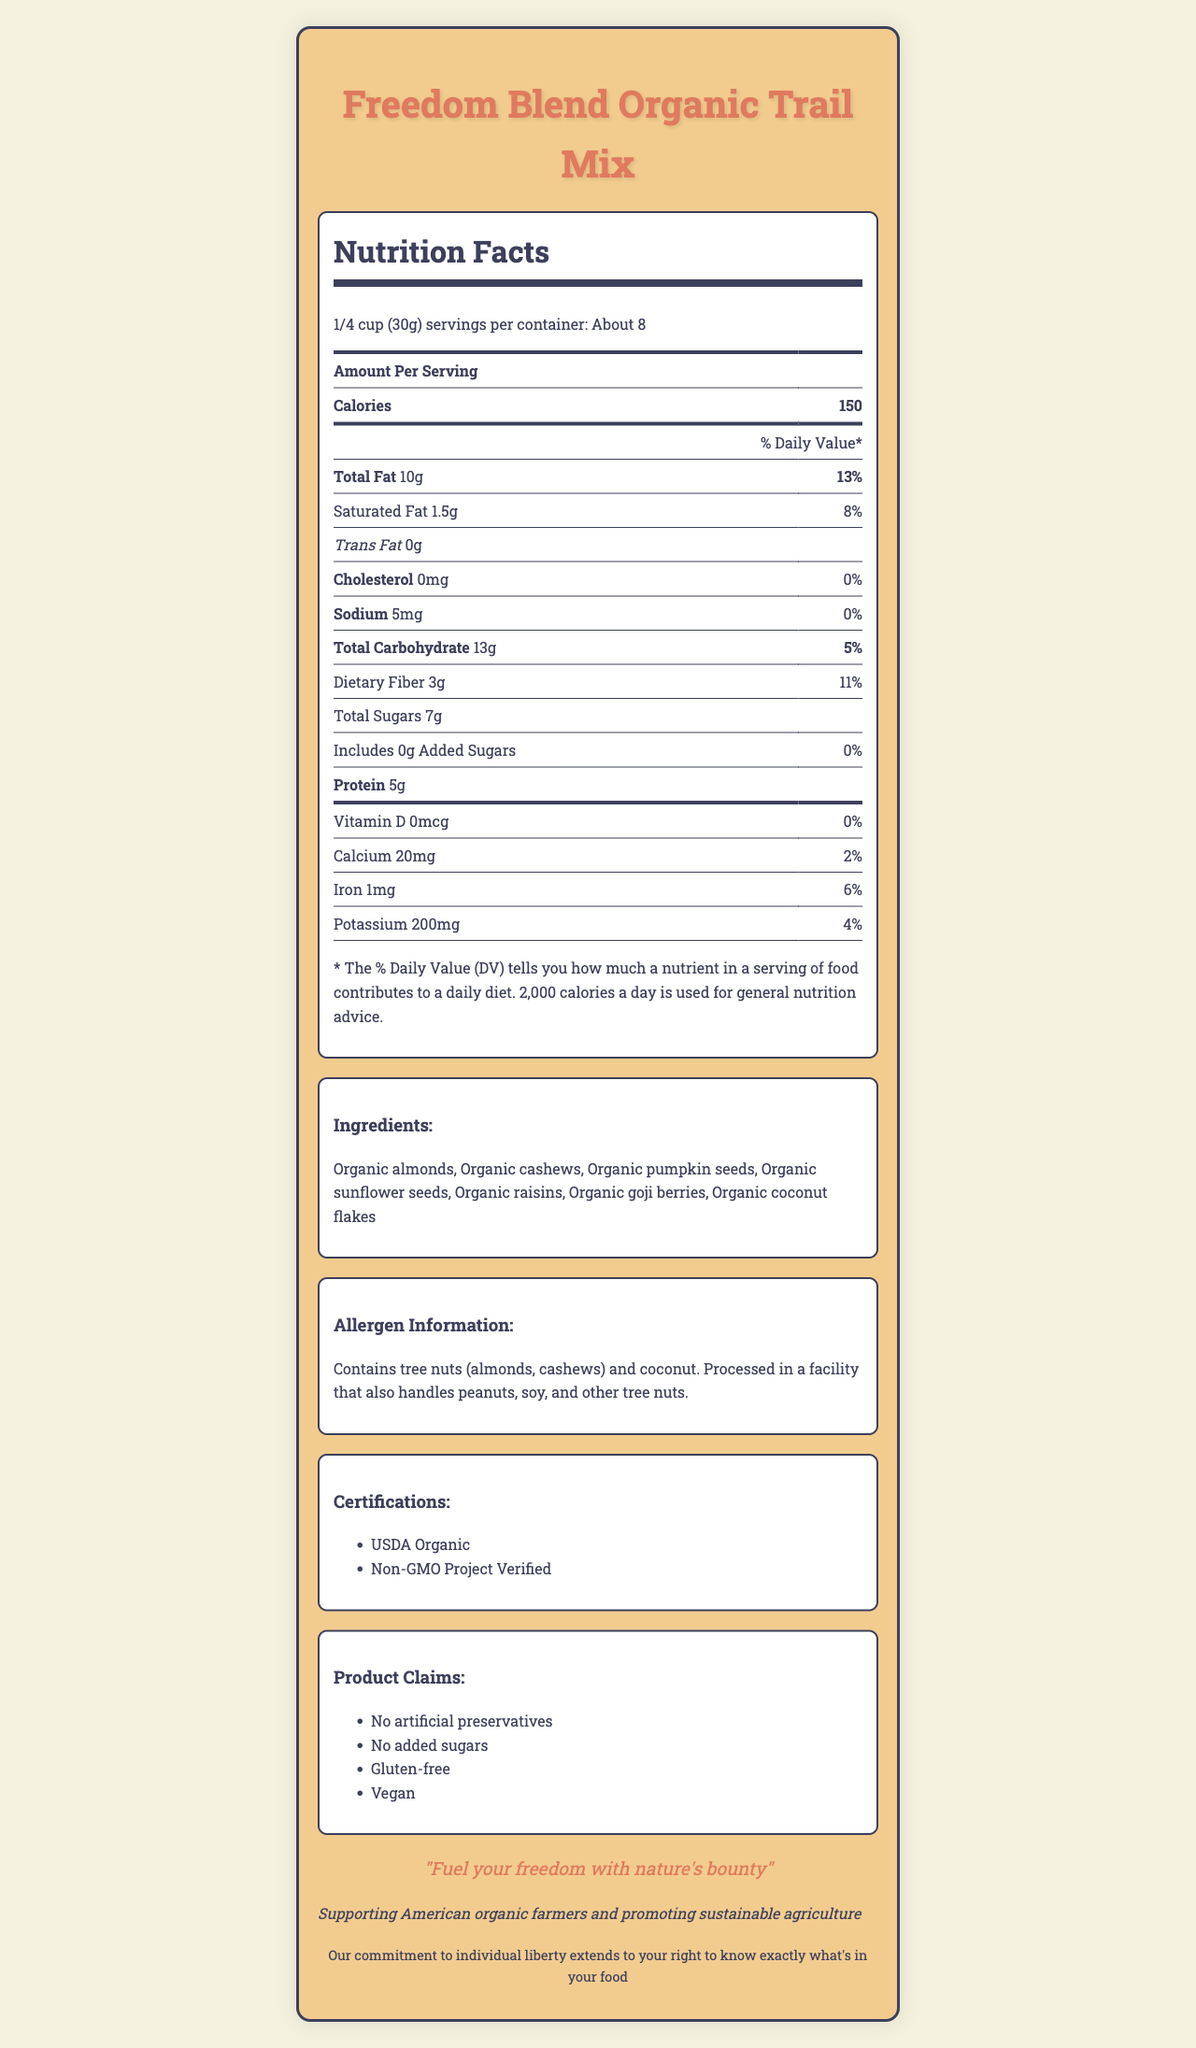1. What is the serving size of the Freedom Blend Organic Trail Mix? The serving size is listed at the top of the Nutrition Facts label.
Answer: 1/4 cup (30g) 2. How many calories are in a serving of Freedom Blend Organic Trail Mix? The calorie content per serving is clearly stated under the Nutrition Facts.
Answer: 150 3. How much total fat is in a serving of the trail mix, and what percentage of the daily value does it represent? The Nutrition Facts label specifies 10g of total fat, which is 13% of the daily value.
Answer: 10g, 13% 4. What are the first three ingredients listed on the trail mix? The ingredients are listed under the ingredients section.
Answer: Organic almonds, Organic cashews, Organic pumpkin seeds 5. How many grams of dietary fiber are in a serving, and what percentage of the daily value does this provide? This information can be found under the dietary fiber section of the Nutrition Facts.
Answer: 3g, 11% 1. Which of the following allergens are present in the Freedom Blend Organic Trail Mix? 
A. Dairy 
B. Peanuts 
C. Tree Nuts
D. Soy The allergen information section lists tree nuts (almonds, cashews) as allergens.
Answer: C. Tree Nuts 2. The Freedom Blend Organic Trail Mix claims to contain which of the following? 
i. No artificial preservatives 
ii. No added sugars 
iii. Gluten-free 
iv. Vegan 
A. i and ii only 
B. ii and iii only 
C. iii and iv only 
D. All of the above The marketing claims section includes all four claims.
Answer: D. All of the above Does the trail mix contain any cholesterol? The nutrition label shows 0mg of cholesterol.
Answer: No Summarize the key features of the Freedom Blend Organic Trail Mix as described in the document. This summary captures the essential nutritional information, ingredients, claims, and certifications, reflecting the main points conveyed in the document.
Answer: The Freedom Blend Organic Trail Mix is an organic, non-GMO product featuring a variety of natural ingredients such as almonds, cashews, pumpkin seeds, sunflower seeds, raisins, goji berries, and coconut flakes. It provides 150 calories per 1/4 cup serving, with 10g of total fat (13% daily value) and 3g of dietary fiber (11% daily value). The product is gluten-free, vegan, and contains no artificial preservatives or added sugars. It is certified USDA Organic and Non-GMO Project Verified. The product supports American organic farmers and promotes sustainable agriculture. What is the price of the Freedom Blend Organic Trail Mix? The document does not provide any info about the price of the product.
Answer: Not enough information 